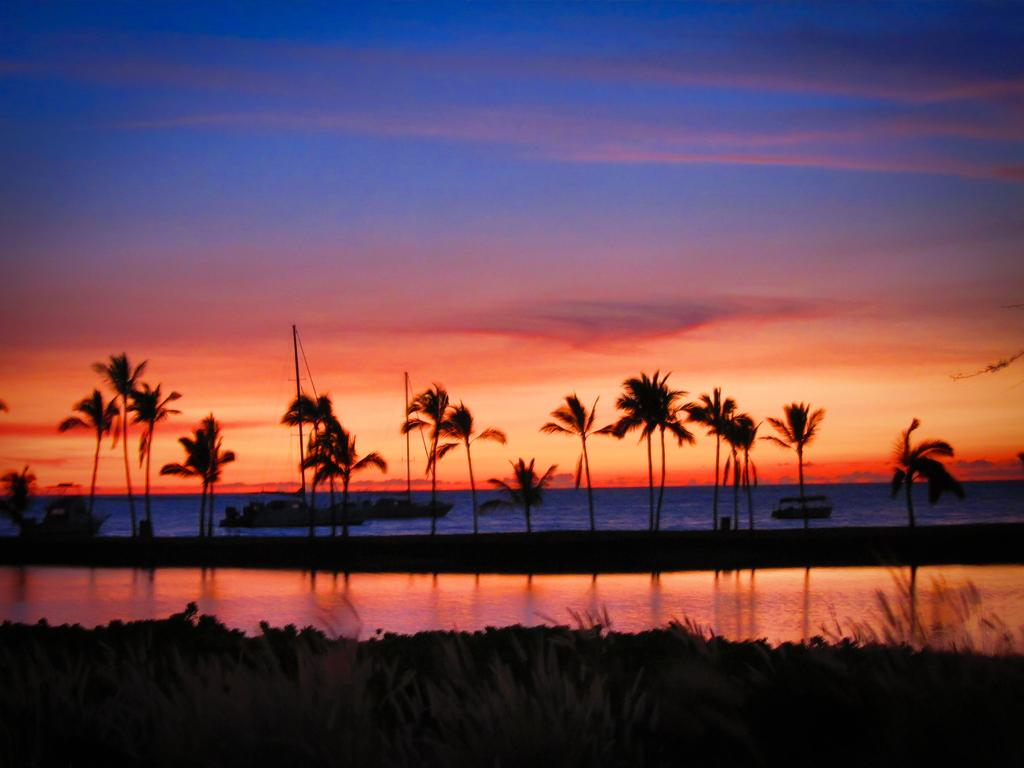What type of vegetation can be seen in the image? There are trees in the image. What else can be seen on the ground in the image? There is grass in the image. What is the water in the image being used for? There are boats on water in the image, suggesting that the water is being used for boating or transportation. What is visible in the background of the image? The sky is visible in the background of the image. How many low bulbs are hanging from the arch in the image? There is no arch or low bulbs present in the image; it features trees, grass, boats, and water. 